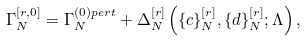<formula> <loc_0><loc_0><loc_500><loc_500>\Gamma _ { N } ^ { [ r , 0 ] } = \Gamma _ { N } ^ { ( 0 ) p e r t } + \Delta _ { N } ^ { [ r ] } \left ( \{ c \} _ { N } ^ { [ r ] } , \{ d \} _ { N } ^ { [ r ] } ; \Lambda \right ) ,</formula> 